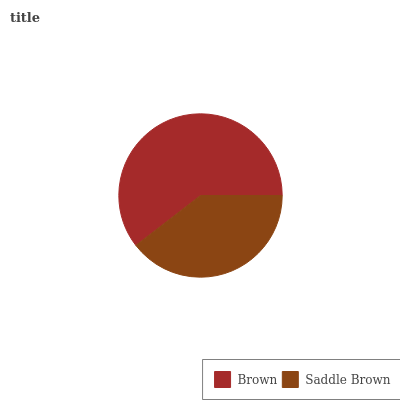Is Saddle Brown the minimum?
Answer yes or no. Yes. Is Brown the maximum?
Answer yes or no. Yes. Is Saddle Brown the maximum?
Answer yes or no. No. Is Brown greater than Saddle Brown?
Answer yes or no. Yes. Is Saddle Brown less than Brown?
Answer yes or no. Yes. Is Saddle Brown greater than Brown?
Answer yes or no. No. Is Brown less than Saddle Brown?
Answer yes or no. No. Is Brown the high median?
Answer yes or no. Yes. Is Saddle Brown the low median?
Answer yes or no. Yes. Is Saddle Brown the high median?
Answer yes or no. No. Is Brown the low median?
Answer yes or no. No. 